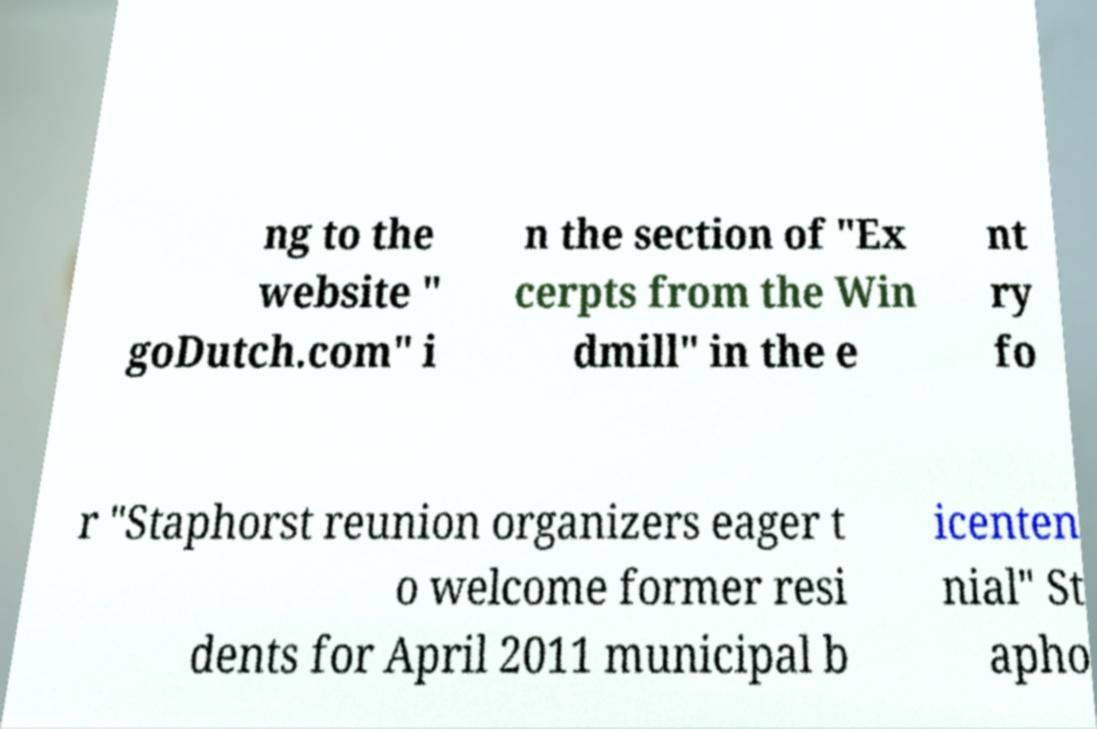Could you extract and type out the text from this image? ng to the website " goDutch.com" i n the section of "Ex cerpts from the Win dmill" in the e nt ry fo r "Staphorst reunion organizers eager t o welcome former resi dents for April 2011 municipal b icenten nial" St apho 